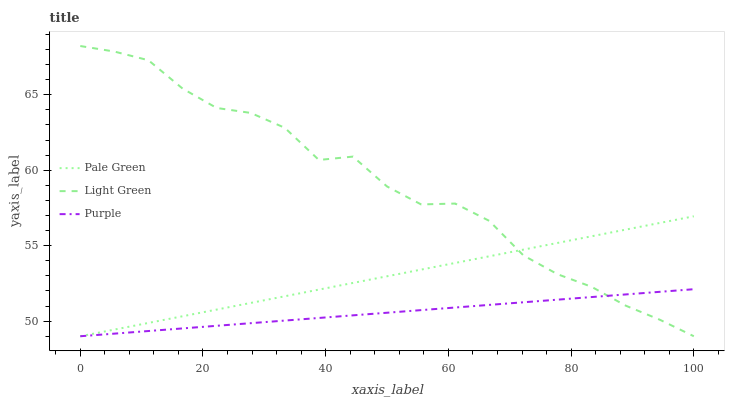Does Pale Green have the minimum area under the curve?
Answer yes or no. No. Does Pale Green have the maximum area under the curve?
Answer yes or no. No. Is Light Green the smoothest?
Answer yes or no. No. Is Pale Green the roughest?
Answer yes or no. No. Does Pale Green have the highest value?
Answer yes or no. No. 